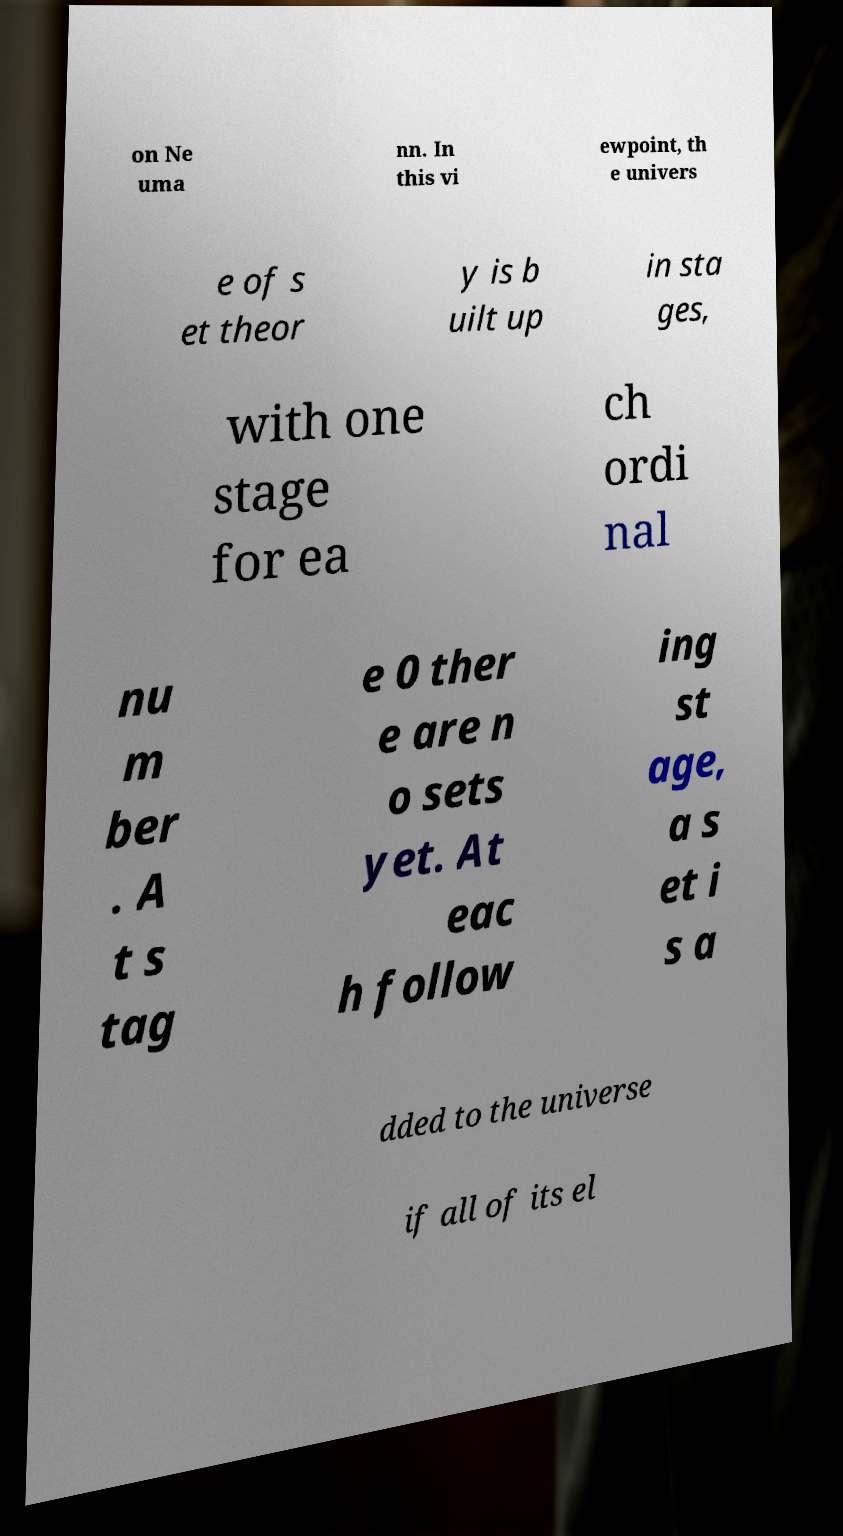Please identify and transcribe the text found in this image. on Ne uma nn. In this vi ewpoint, th e univers e of s et theor y is b uilt up in sta ges, with one stage for ea ch ordi nal nu m ber . A t s tag e 0 ther e are n o sets yet. At eac h follow ing st age, a s et i s a dded to the universe if all of its el 